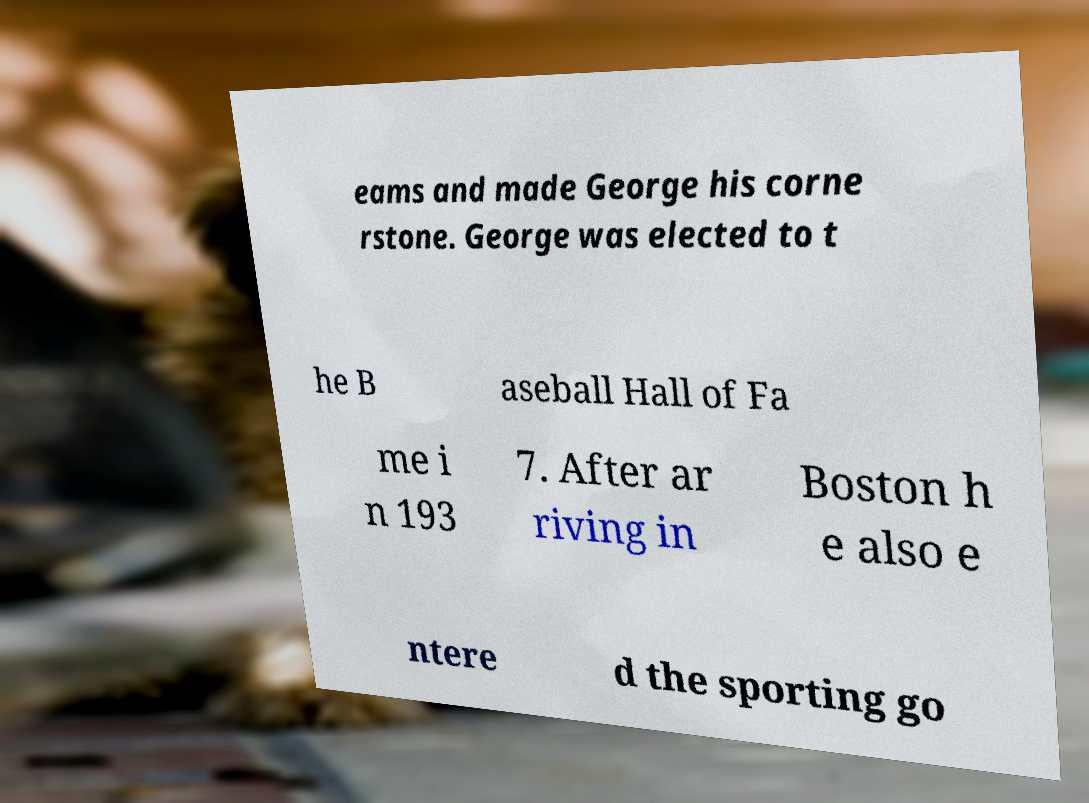Please read and relay the text visible in this image. What does it say? eams and made George his corne rstone. George was elected to t he B aseball Hall of Fa me i n 193 7. After ar riving in Boston h e also e ntere d the sporting go 